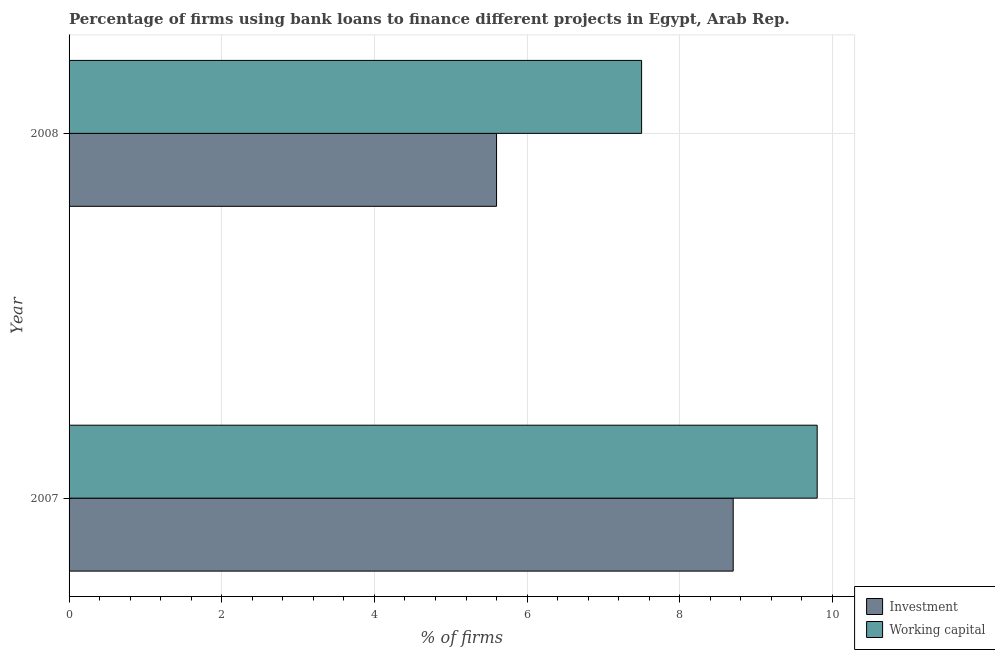How many different coloured bars are there?
Offer a terse response. 2. Are the number of bars per tick equal to the number of legend labels?
Make the answer very short. Yes. How many bars are there on the 1st tick from the top?
Your answer should be compact. 2. Across all years, what is the minimum percentage of firms using banks to finance investment?
Offer a very short reply. 5.6. In which year was the percentage of firms using banks to finance working capital maximum?
Make the answer very short. 2007. What is the total percentage of firms using banks to finance investment in the graph?
Provide a succinct answer. 14.3. What is the difference between the percentage of firms using banks to finance working capital in 2008 and the percentage of firms using banks to finance investment in 2007?
Your answer should be very brief. -1.2. What is the average percentage of firms using banks to finance working capital per year?
Offer a very short reply. 8.65. In the year 2007, what is the difference between the percentage of firms using banks to finance working capital and percentage of firms using banks to finance investment?
Your answer should be very brief. 1.1. What is the ratio of the percentage of firms using banks to finance working capital in 2007 to that in 2008?
Your answer should be very brief. 1.31. Is the difference between the percentage of firms using banks to finance working capital in 2007 and 2008 greater than the difference between the percentage of firms using banks to finance investment in 2007 and 2008?
Offer a terse response. No. What does the 2nd bar from the top in 2007 represents?
Provide a succinct answer. Investment. What does the 1st bar from the bottom in 2008 represents?
Offer a very short reply. Investment. How many bars are there?
Keep it short and to the point. 4. Are all the bars in the graph horizontal?
Give a very brief answer. Yes. What is the difference between two consecutive major ticks on the X-axis?
Your answer should be compact. 2. What is the title of the graph?
Offer a very short reply. Percentage of firms using bank loans to finance different projects in Egypt, Arab Rep. Does "Investment" appear as one of the legend labels in the graph?
Offer a terse response. Yes. What is the label or title of the X-axis?
Ensure brevity in your answer.  % of firms. What is the % of firms of Investment in 2008?
Ensure brevity in your answer.  5.6. Across all years, what is the minimum % of firms of Investment?
Your answer should be compact. 5.6. Across all years, what is the minimum % of firms of Working capital?
Ensure brevity in your answer.  7.5. What is the total % of firms in Investment in the graph?
Keep it short and to the point. 14.3. What is the average % of firms in Investment per year?
Offer a terse response. 7.15. What is the average % of firms in Working capital per year?
Provide a succinct answer. 8.65. What is the ratio of the % of firms of Investment in 2007 to that in 2008?
Keep it short and to the point. 1.55. What is the ratio of the % of firms in Working capital in 2007 to that in 2008?
Your answer should be compact. 1.31. What is the difference between the highest and the lowest % of firms in Investment?
Offer a very short reply. 3.1. 